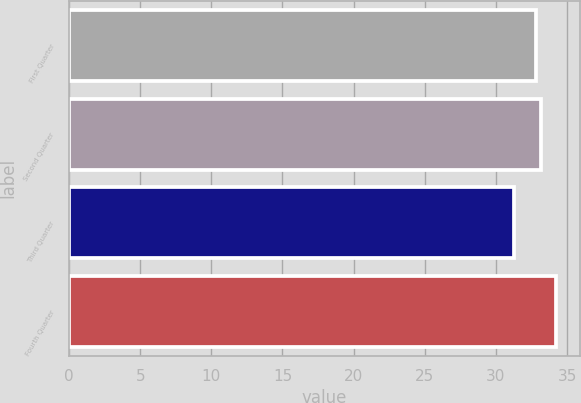Convert chart to OTSL. <chart><loc_0><loc_0><loc_500><loc_500><bar_chart><fcel>First Quarter<fcel>Second Quarter<fcel>Third Quarter<fcel>Fourth Quarter<nl><fcel>32.83<fcel>33.17<fcel>31.3<fcel>34.2<nl></chart> 